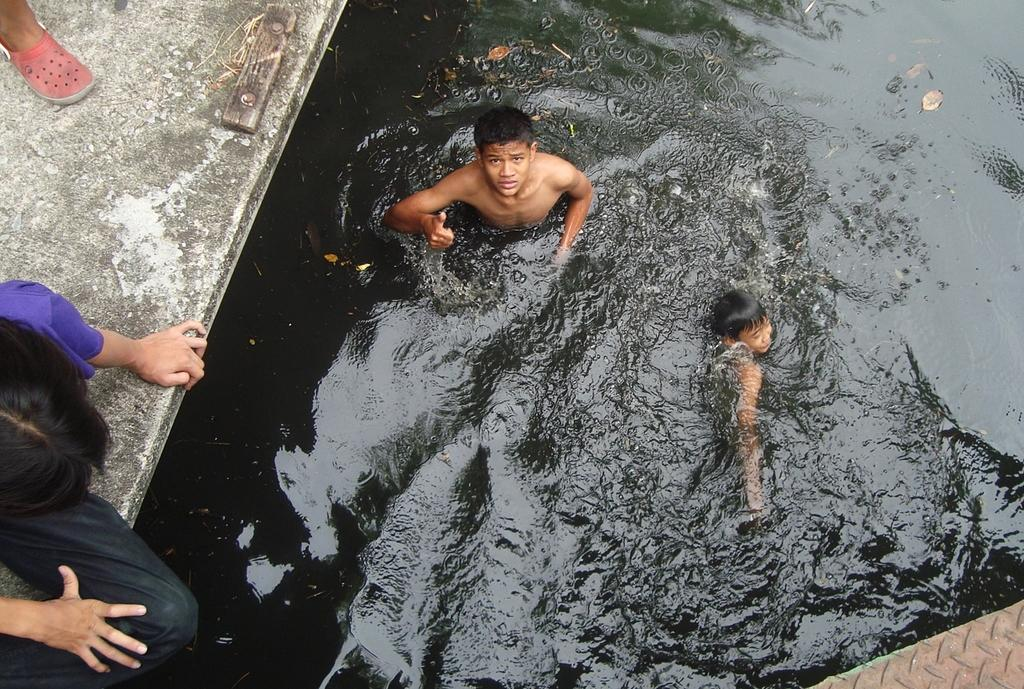What are the two people in the image doing? The two people in the image are in the water. What is the position of the person sitting on the left side of the image? There is a person sitting on a platform on the left side of the image. Can you describe the position of the leg visible beside the person sitting on the platform? The leg of a person is visible beside the person sitting on the platform. What type of business is being conducted by the person sitting on the platform in the image? There is no indication of any business being conducted in the image; it primarily features people in the water and a person sitting on a platform. 